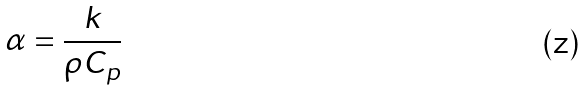<formula> <loc_0><loc_0><loc_500><loc_500>\alpha = \frac { k } { \rho C _ { p } }</formula> 